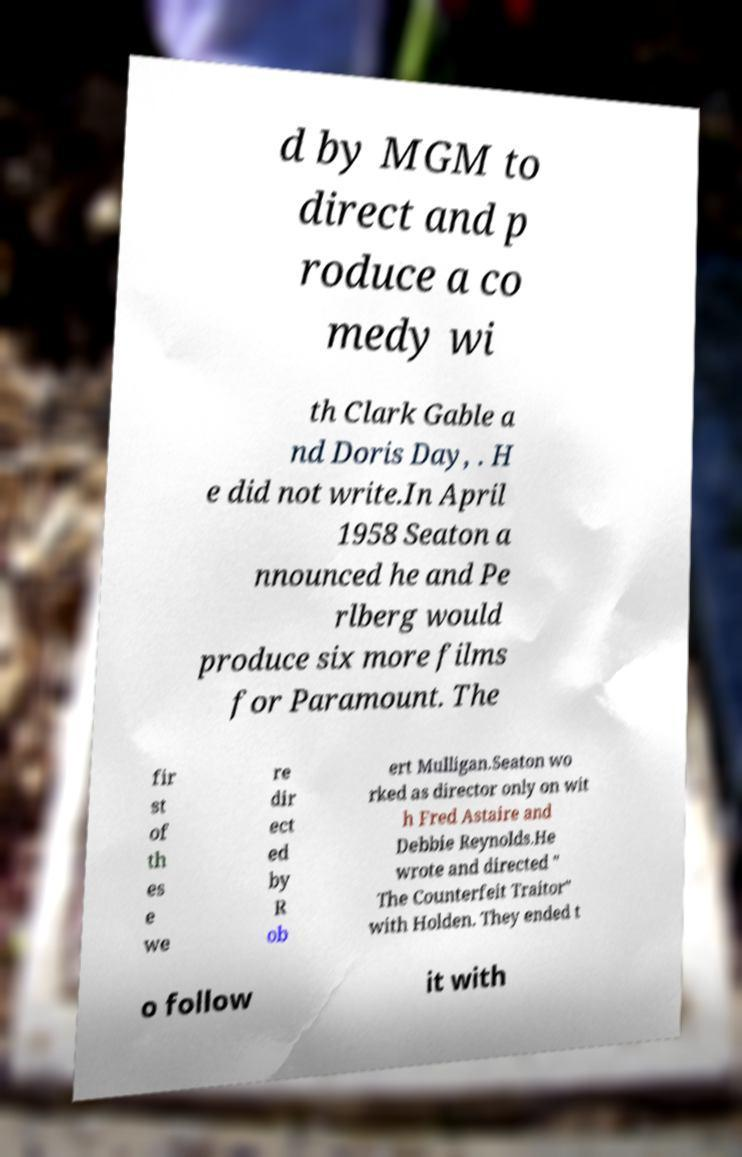There's text embedded in this image that I need extracted. Can you transcribe it verbatim? d by MGM to direct and p roduce a co medy wi th Clark Gable a nd Doris Day, . H e did not write.In April 1958 Seaton a nnounced he and Pe rlberg would produce six more films for Paramount. The fir st of th es e we re dir ect ed by R ob ert Mulligan.Seaton wo rked as director only on wit h Fred Astaire and Debbie Reynolds.He wrote and directed " The Counterfeit Traitor" with Holden. They ended t o follow it with 